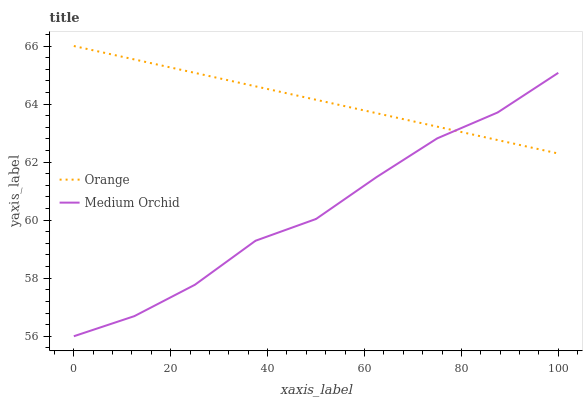Does Medium Orchid have the maximum area under the curve?
Answer yes or no. No. Is Medium Orchid the smoothest?
Answer yes or no. No. Does Medium Orchid have the highest value?
Answer yes or no. No. 